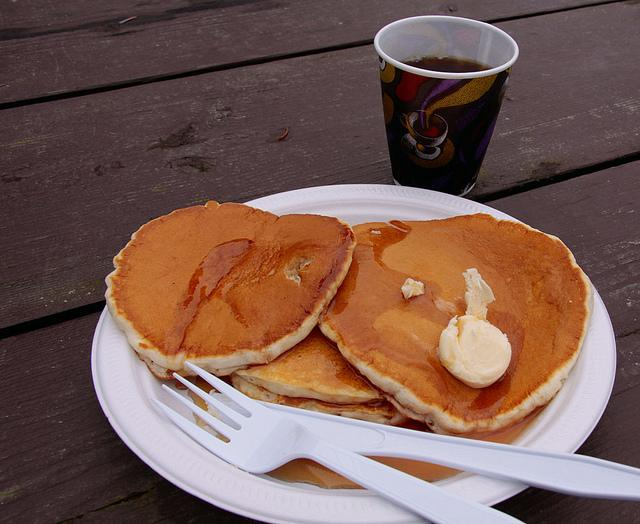On what surface is this plate of pancakes placed upon? picnic table 